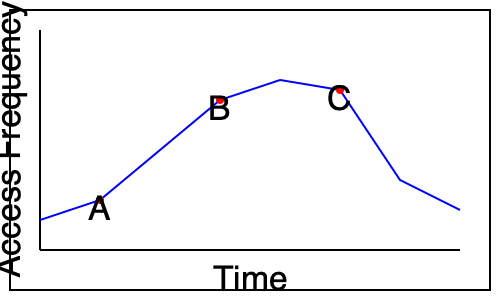Based on the access pattern shown in the graph, which Guava Cache eviction strategy would be most appropriate for optimizing cache performance? To determine the most appropriate Guava Cache eviction strategy, let's analyze the access pattern:

1. The graph shows access frequency over time for cached items.
2. We can observe three distinct peaks (A, B, and C) in the access pattern.
3. The access frequency rises and falls periodically, indicating temporal locality.
4. There's a general trend of decreasing access frequency over time.

Given these observations, we can consider the following Guava Cache eviction strategies:

a) LRU (Least Recently Used): This strategy would work, but it might not be optimal for this pattern as it doesn't consider frequency.

b) LFU (Least Frequently Used): This strategy could work well for the high-frequency items but might retain items that were frequently accessed in the past but are no longer needed.

c) FIFO (First-In-First-Out): This strategy wouldn't be suitable as it doesn't consider the frequency or recency of access.

d) Timed Expiration: This could be useful given the periodic nature of the access pattern, but alone it might not be optimal.

e) Size-based Eviction: This strategy doesn't align well with the observed access pattern.

The most appropriate strategy for this access pattern would be a combination of strategies:

1. Time-based expiration to account for the periodic nature of accesses.
2. A frequency-based strategy to prioritize frequently accessed items.

Guava's `CacheBuilder` allows us to combine these strategies using:

- `expireAfterWrite()` or `expireAfterAccess()` for time-based expiration
- `weigher()` and `maximumWeight()` to implement a custom frequency-based eviction policy

This combination would ensure that:
- Items are evicted after a certain time to align with the periodic access pattern.
- Frequently accessed items within each period are retained longer.

Therefore, the most appropriate Guava Cache eviction strategy would be a custom implementation combining time-based expiration and frequency-based weighing.
Answer: Custom strategy combining time-based expiration and frequency-based weighing 